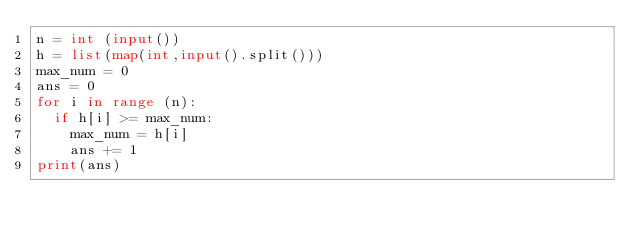<code> <loc_0><loc_0><loc_500><loc_500><_Python_>n = int (input())
h = list(map(int,input().split()))
max_num = 0
ans = 0
for i in range (n):
  if h[i] >= max_num:
    max_num = h[i]
    ans += 1
print(ans)</code> 